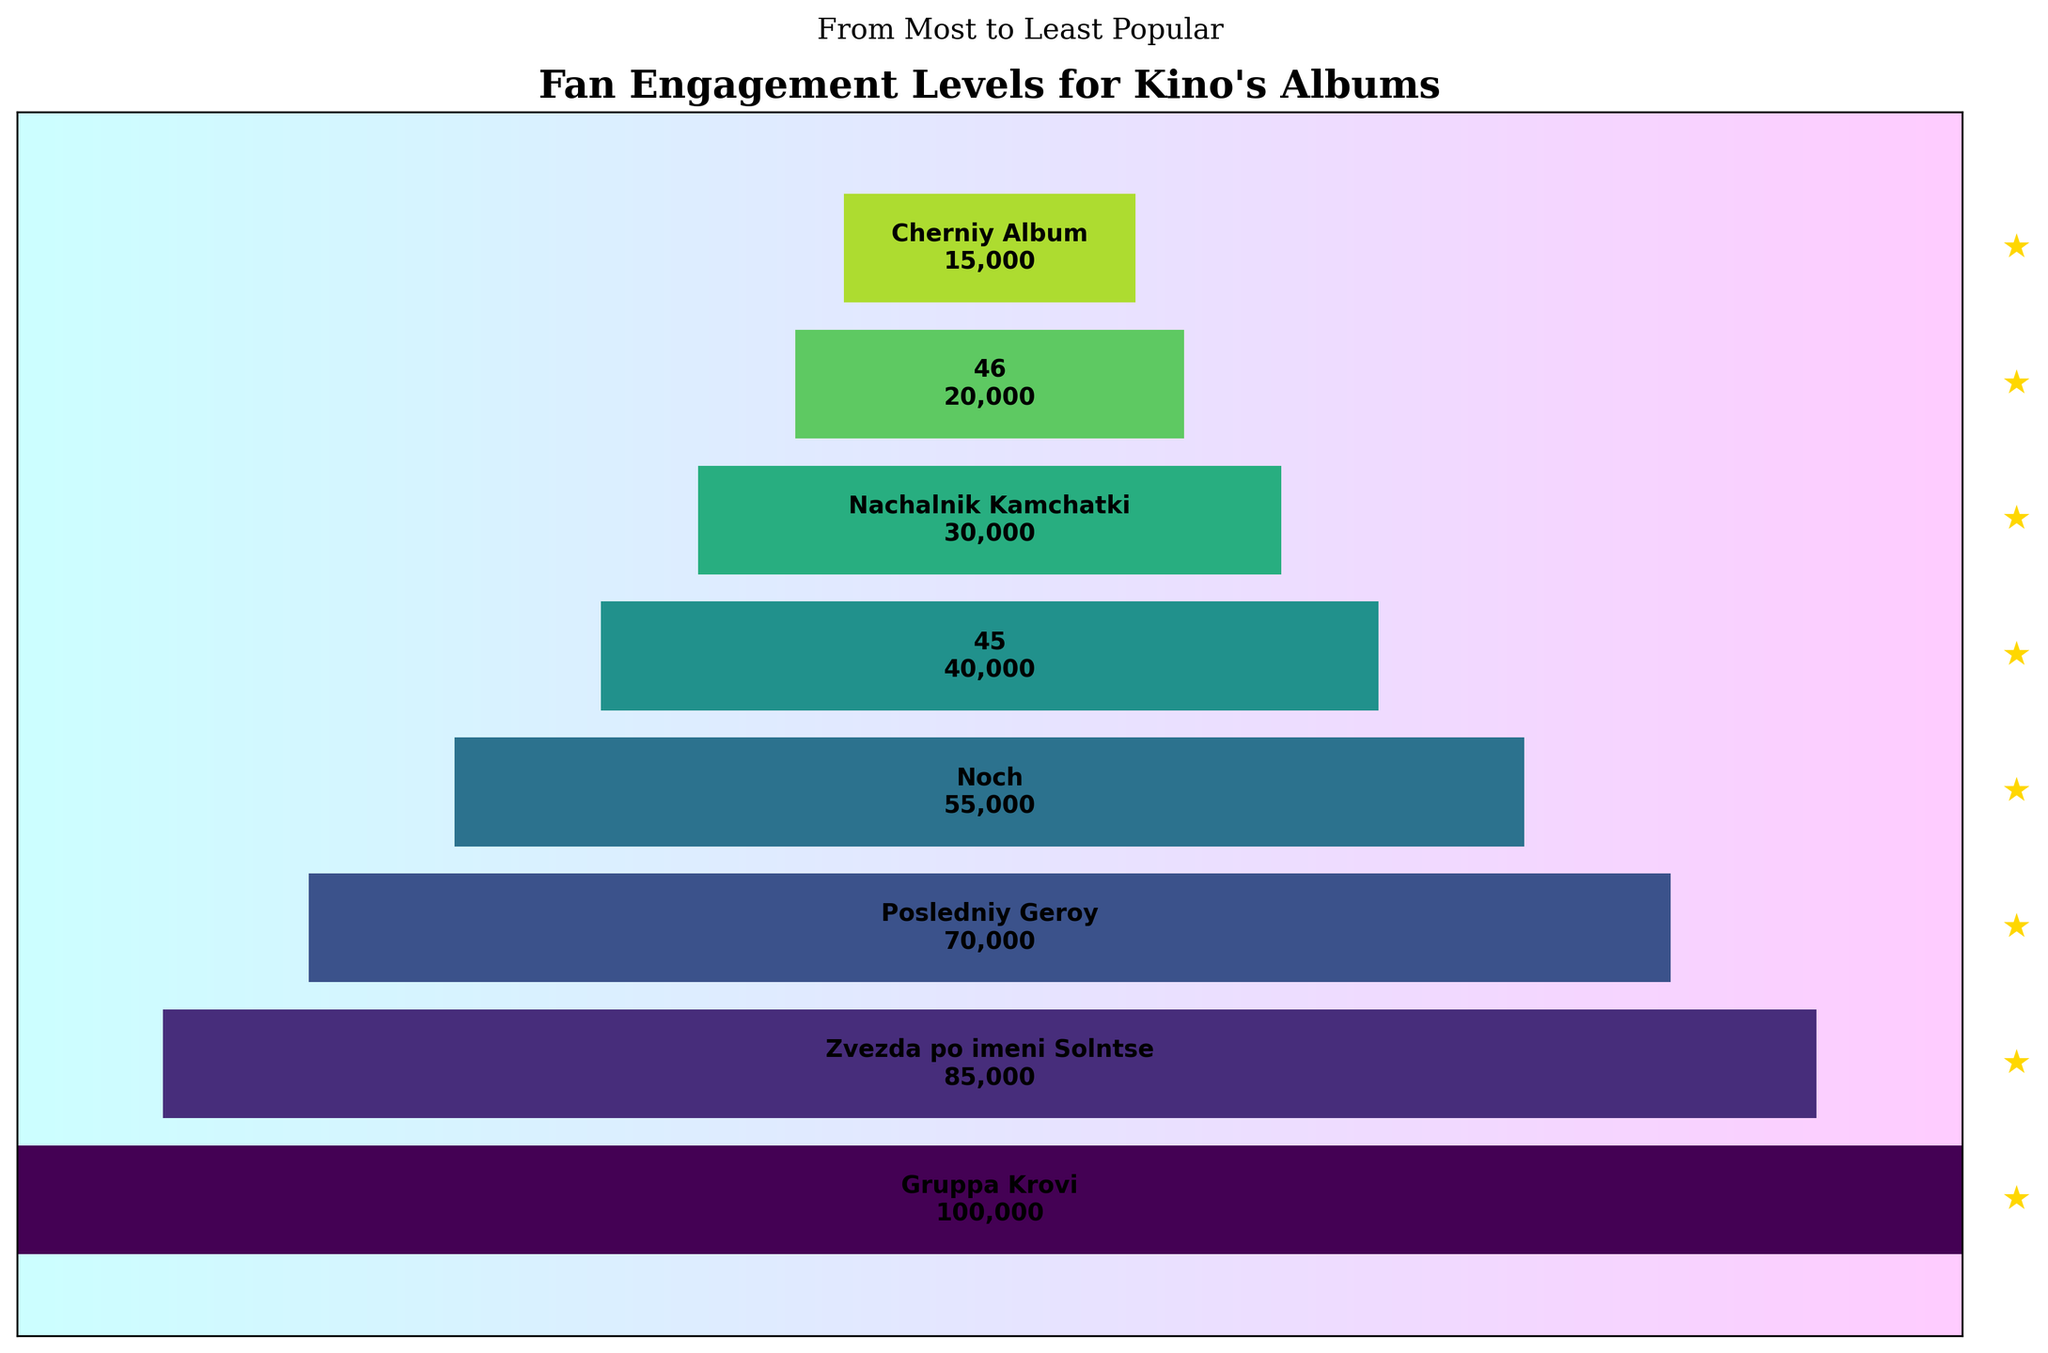How many albums are there in total in the funnel chart? There are 8 different albums listed in the funnel chart, each with its corresponding engagement level. We can count the total number of albums by looking at each named segment.
Answer: 8 Which album has the highest fan engagement level? The segment with the widest width and the highest value text indicates the highest engagement level. "Gruppa Krovi" shows an engagement level of 100,000, the highest in the chart.
Answer: Gruppa Krovi Compare the fan engagement level of "Noch" and "Zvezda po imeni Solntse". Which one is higher, and by how much? "Noch" has an engagement level of 55,000, while "Zvezda po imeni Solntse" has an engagement level of 85,000. So, 85,000 - 55,000 = 30,000.
Answer: Zvezda po imeni Solntse, by 30,000 What is the total fan engagement for the least three popular albums? The least three popular albums are "Cherniy Album" (15,000), "46" (20,000), and "Nachalnik Kamchatki" (30,000). Adding these levels gives 15,000 + 20,000 + 30,000 = 65,000
Answer: 65,000 How much more popular is "Zvezda po imeni Solntse" compared to "Posledniy Geroy"? "Zvezda po imeni Solntse" has an engagement level of 85,000, and "Posledniy Geroy" has an engagement level of 70,000. The difference is 85,000 - 70,000 = 15,000.
Answer: 15,000 If the engagement level of "Gruppa Krovi" is hypothetically reduced by 50%, what would be the new engagement level? The current engagement level of "Gruppa Krovi" is 100,000. Reducing it by 50%: 100,000 * 0.5 = 50,000.
Answer: 50,000 Which albums have an engagement level higher than 50,000? The albums are listed with their engagement levels: "Gruppa Krovi" (100,000), "Zvezda po imeni Solntse" (85,000), "Posledniy Geroy" (70,000), and "Noch" (55,000) all have engagement levels higher than 50,000.
Answer: Gruppa Krovi, Zvezda po imeni Solntse, Posledniy Geroy, Noch What is the average fan engagement level of all albums? Summing all engagement levels: 100,000 + 85,000 + 70,000 + 55,000 + 40,000 + 30,000 + 20,000 + 15,000 = 415,000. There are 8 albums, so the average is 415,000 / 8 = 51,875.
Answer: 51,875 How does the fan engagement level of "Noch" compare to the average fan engagement level? "Noch" has an engagement level of 55,000. The average engagement level is 51,875. Since 55,000 is greater than 51,875, "Noch" is above average.
Answer: Above average 